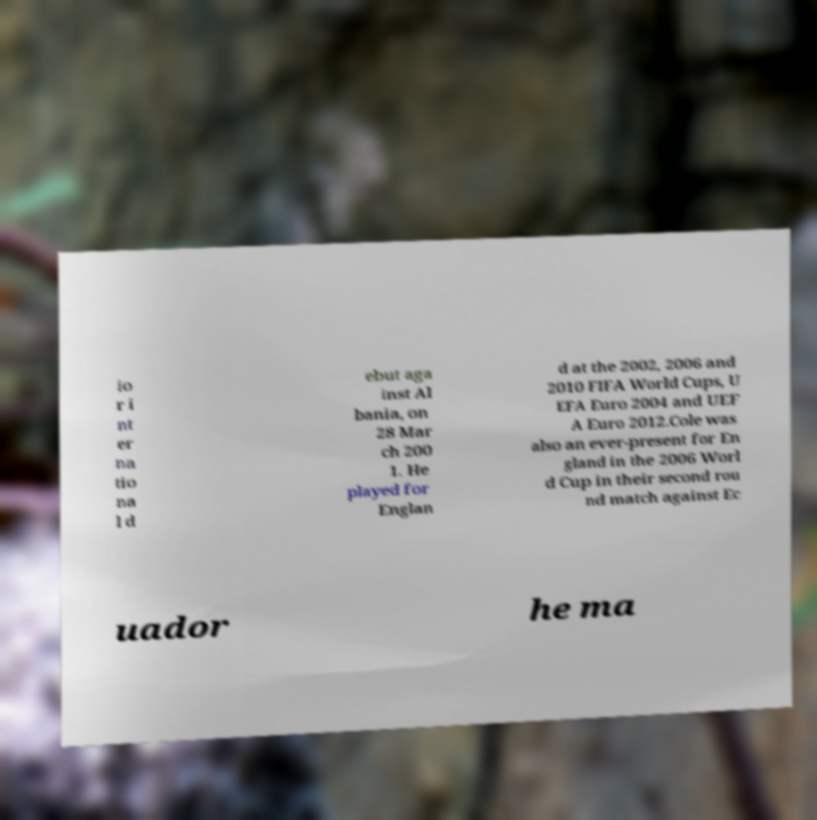Please identify and transcribe the text found in this image. io r i nt er na tio na l d ebut aga inst Al bania, on 28 Mar ch 200 1. He played for Englan d at the 2002, 2006 and 2010 FIFA World Cups, U EFA Euro 2004 and UEF A Euro 2012.Cole was also an ever-present for En gland in the 2006 Worl d Cup in their second rou nd match against Ec uador he ma 